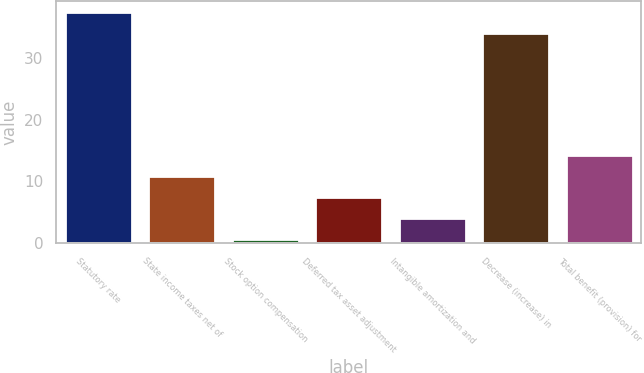<chart> <loc_0><loc_0><loc_500><loc_500><bar_chart><fcel>Statutory rate<fcel>State income taxes net of<fcel>Stock option compensation<fcel>Deferred tax asset adjustment<fcel>Intangible amortization and<fcel>Decrease (increase) in<fcel>Total benefit (provision) for<nl><fcel>37.44<fcel>10.92<fcel>0.6<fcel>7.48<fcel>4.04<fcel>34<fcel>14.36<nl></chart> 